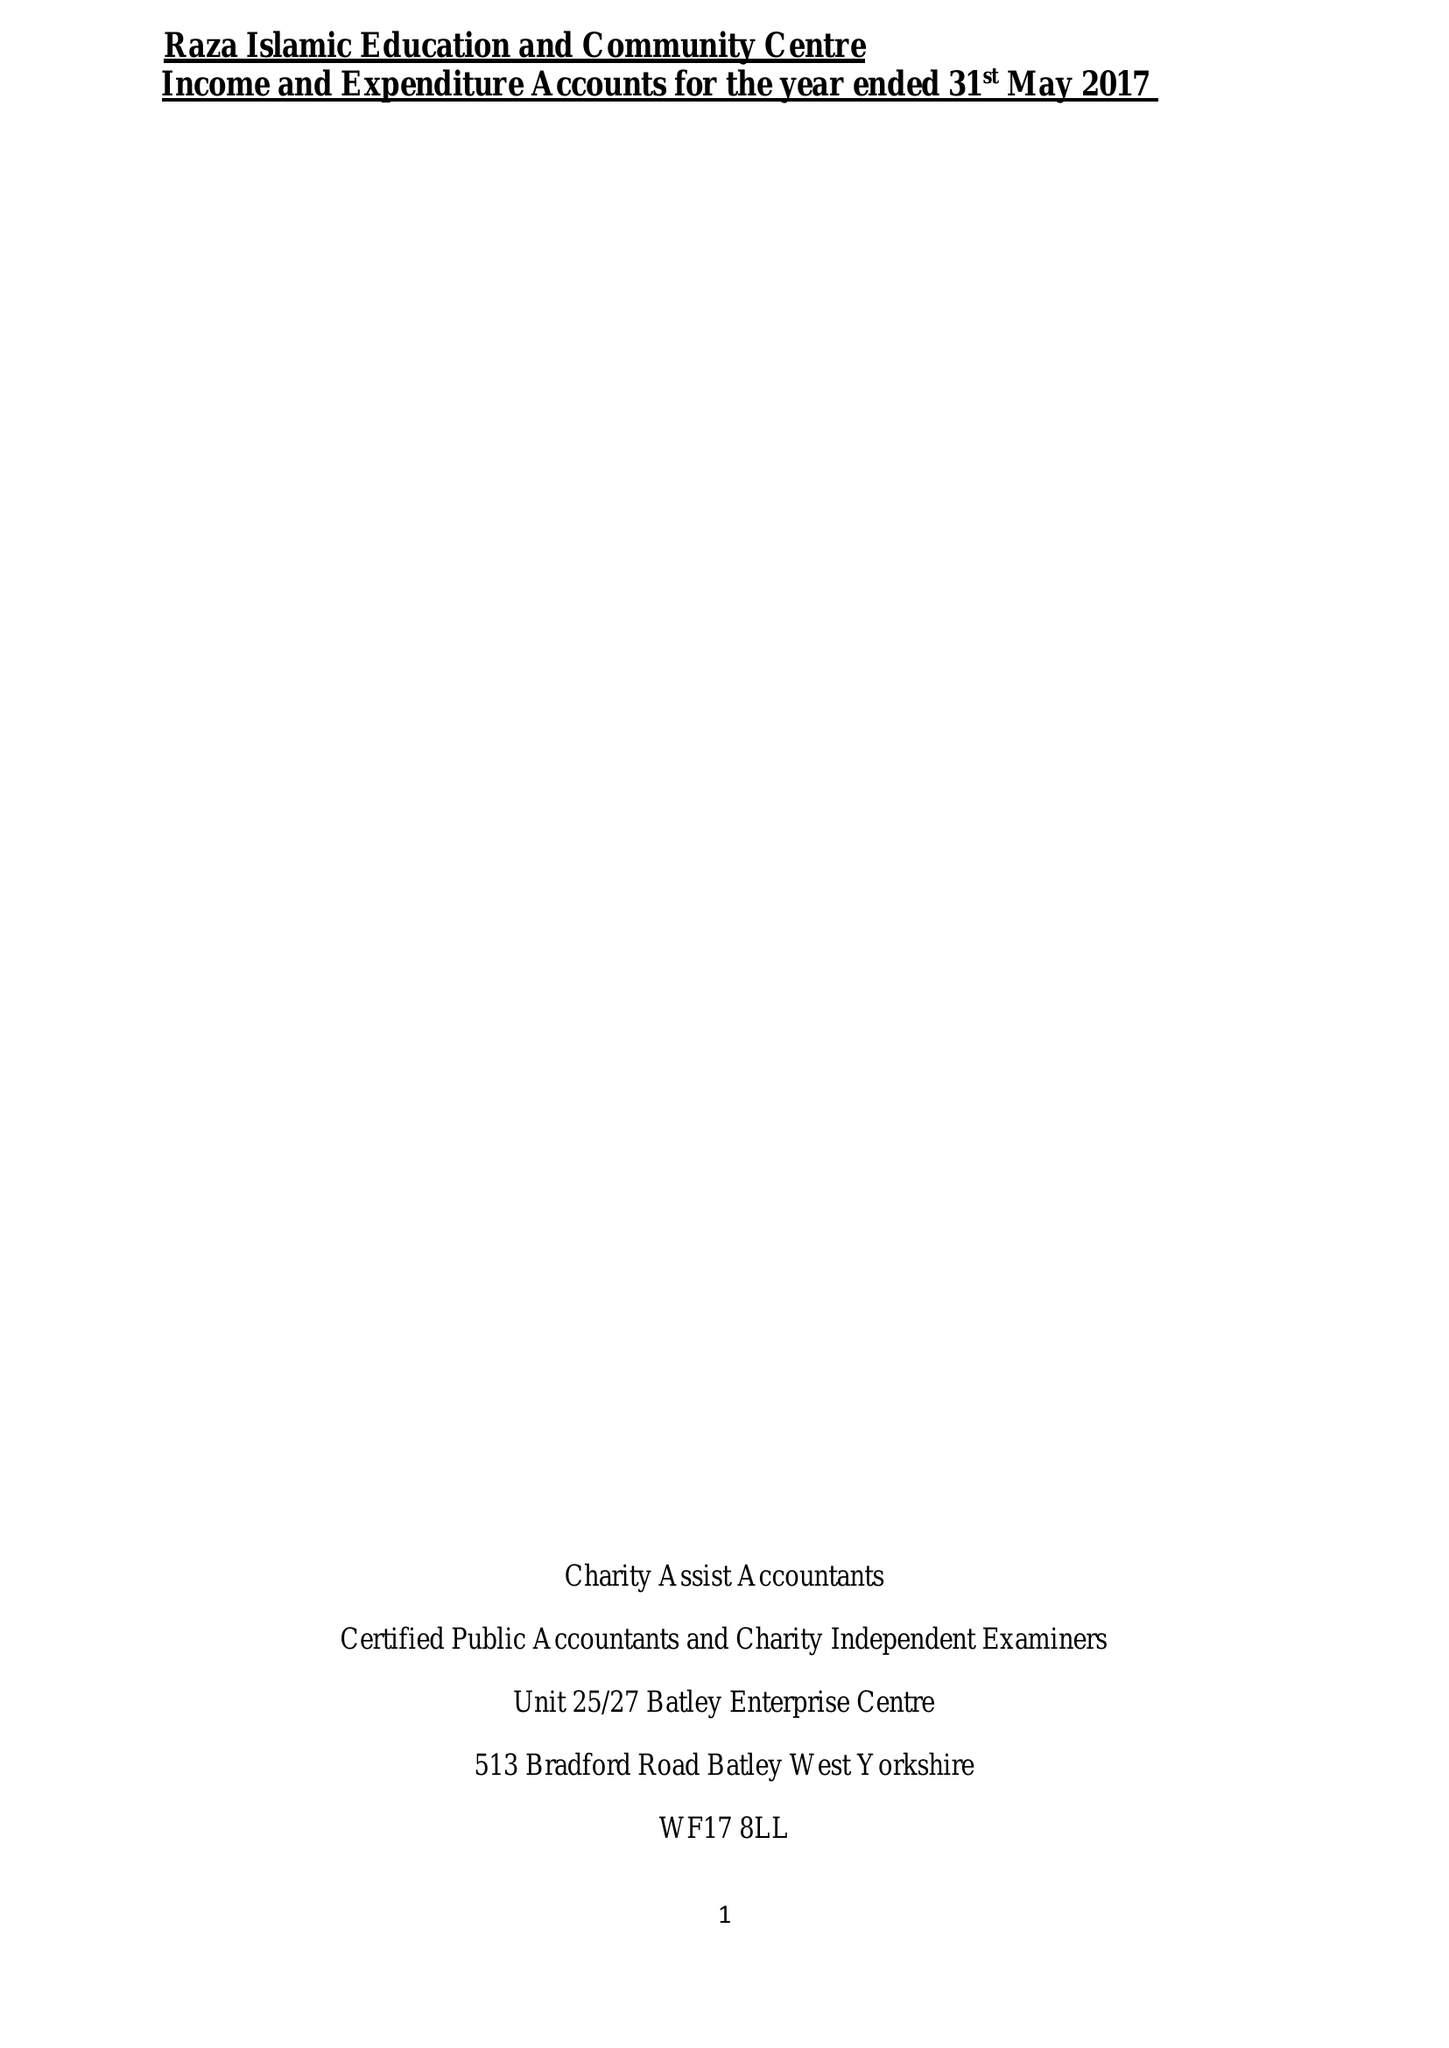What is the value for the address__post_town?
Answer the question using a single word or phrase. DEWSBURY 